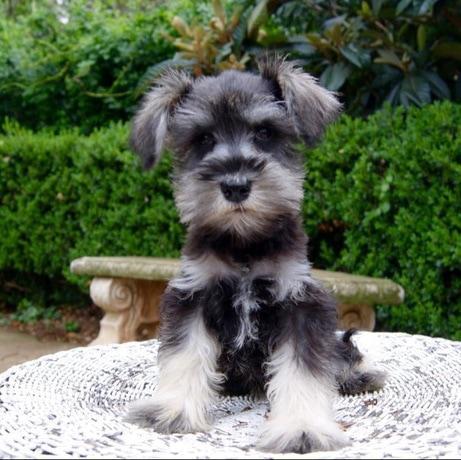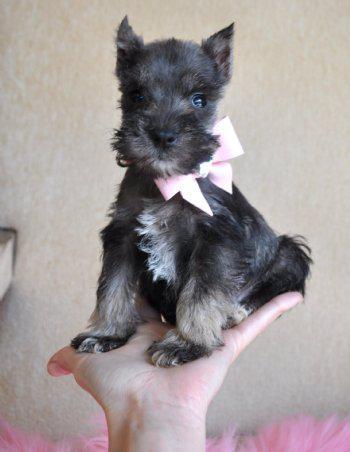The first image is the image on the left, the second image is the image on the right. Examine the images to the left and right. Is the description "One image shows a schnauzer standing and facing toward the right." accurate? Answer yes or no. No. 